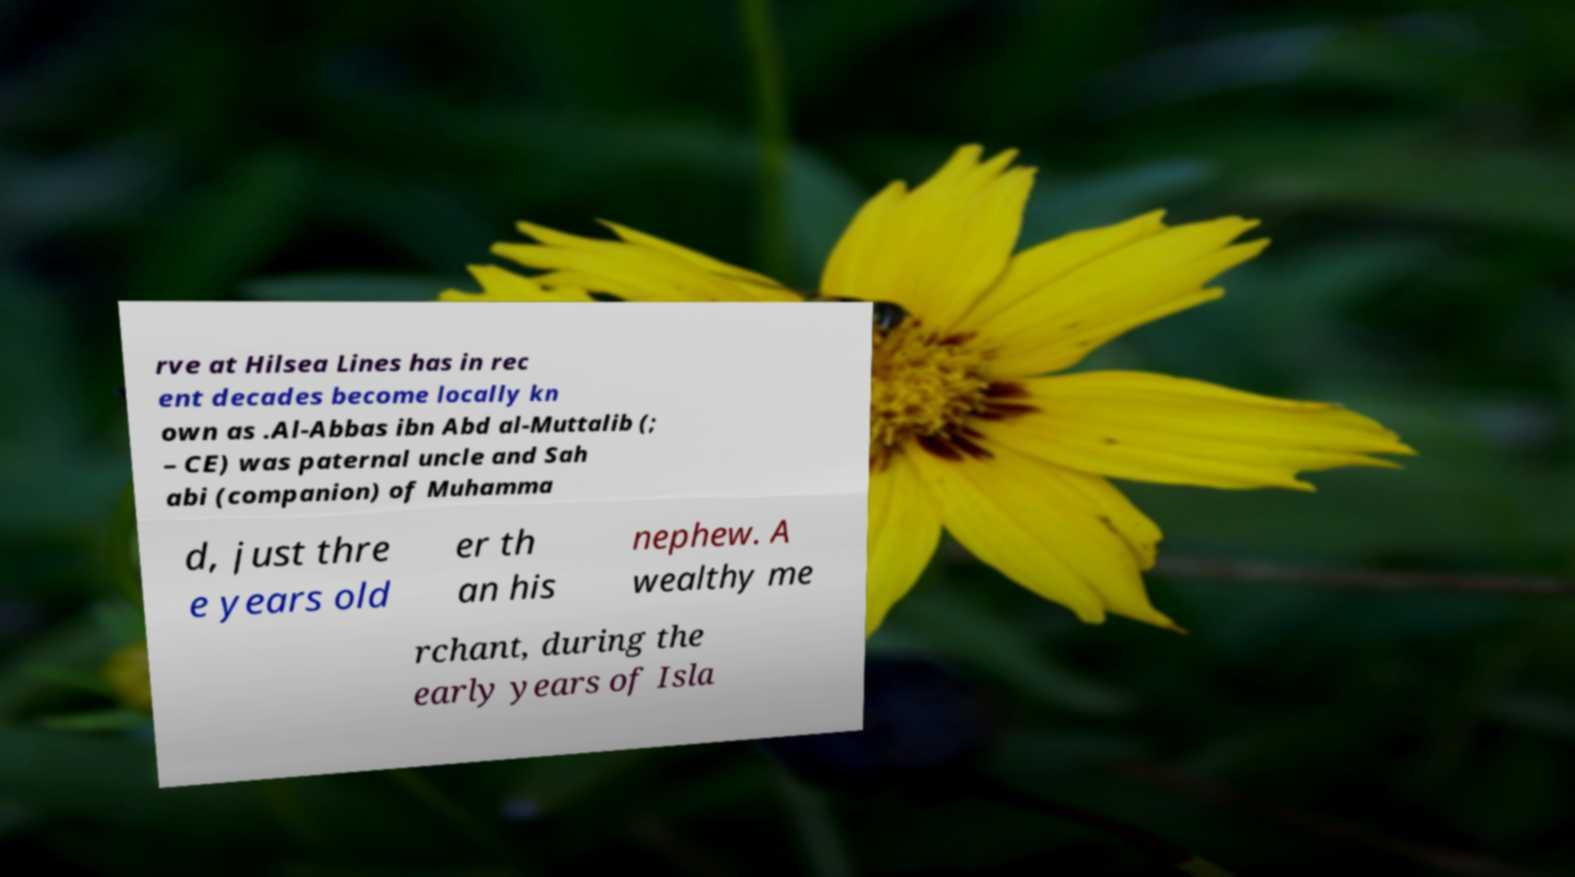Please read and relay the text visible in this image. What does it say? rve at Hilsea Lines has in rec ent decades become locally kn own as .Al-Abbas ibn Abd al-Muttalib (; – CE) was paternal uncle and Sah abi (companion) of Muhamma d, just thre e years old er th an his nephew. A wealthy me rchant, during the early years of Isla 